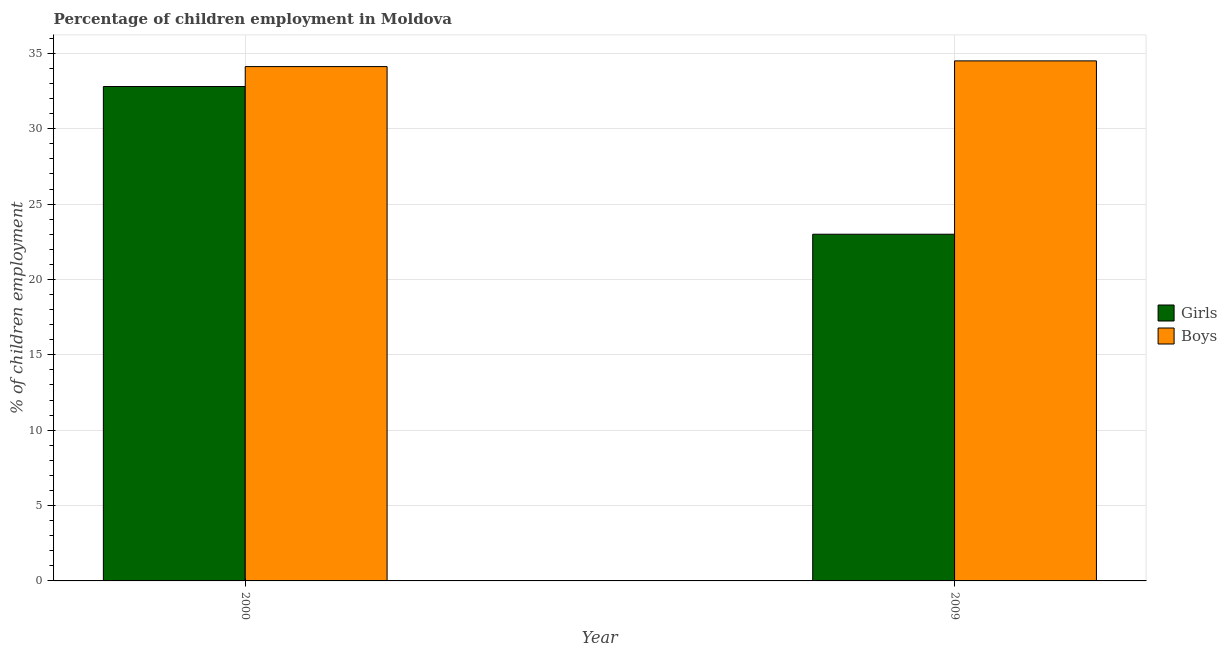How many bars are there on the 1st tick from the right?
Offer a terse response. 2. In how many cases, is the number of bars for a given year not equal to the number of legend labels?
Provide a short and direct response. 0. What is the percentage of employed boys in 2009?
Ensure brevity in your answer.  34.5. Across all years, what is the maximum percentage of employed boys?
Provide a succinct answer. 34.5. Across all years, what is the minimum percentage of employed boys?
Your answer should be very brief. 34.12. What is the total percentage of employed girls in the graph?
Provide a short and direct response. 55.8. What is the difference between the percentage of employed boys in 2000 and that in 2009?
Make the answer very short. -0.38. What is the difference between the percentage of employed girls in 2009 and the percentage of employed boys in 2000?
Ensure brevity in your answer.  -9.8. What is the average percentage of employed boys per year?
Keep it short and to the point. 34.31. In how many years, is the percentage of employed girls greater than 18 %?
Offer a very short reply. 2. What is the ratio of the percentage of employed boys in 2000 to that in 2009?
Offer a very short reply. 0.99. What does the 1st bar from the left in 2009 represents?
Keep it short and to the point. Girls. What does the 2nd bar from the right in 2009 represents?
Provide a succinct answer. Girls. How many years are there in the graph?
Your answer should be very brief. 2. What is the difference between two consecutive major ticks on the Y-axis?
Provide a short and direct response. 5. Are the values on the major ticks of Y-axis written in scientific E-notation?
Offer a terse response. No. How are the legend labels stacked?
Provide a succinct answer. Vertical. What is the title of the graph?
Your response must be concise. Percentage of children employment in Moldova. What is the label or title of the X-axis?
Your response must be concise. Year. What is the label or title of the Y-axis?
Your answer should be very brief. % of children employment. What is the % of children employment in Girls in 2000?
Your response must be concise. 32.8. What is the % of children employment of Boys in 2000?
Keep it short and to the point. 34.12. What is the % of children employment of Girls in 2009?
Offer a very short reply. 23. What is the % of children employment in Boys in 2009?
Give a very brief answer. 34.5. Across all years, what is the maximum % of children employment of Girls?
Offer a very short reply. 32.8. Across all years, what is the maximum % of children employment of Boys?
Keep it short and to the point. 34.5. Across all years, what is the minimum % of children employment in Girls?
Offer a terse response. 23. Across all years, what is the minimum % of children employment of Boys?
Make the answer very short. 34.12. What is the total % of children employment of Girls in the graph?
Offer a very short reply. 55.8. What is the total % of children employment in Boys in the graph?
Keep it short and to the point. 68.62. What is the difference between the % of children employment in Girls in 2000 and that in 2009?
Give a very brief answer. 9.8. What is the difference between the % of children employment of Boys in 2000 and that in 2009?
Make the answer very short. -0.38. What is the average % of children employment in Girls per year?
Offer a terse response. 27.9. What is the average % of children employment of Boys per year?
Offer a terse response. 34.31. In the year 2000, what is the difference between the % of children employment in Girls and % of children employment in Boys?
Offer a terse response. -1.32. What is the ratio of the % of children employment in Girls in 2000 to that in 2009?
Make the answer very short. 1.43. What is the difference between the highest and the second highest % of children employment in Girls?
Your response must be concise. 9.8. What is the difference between the highest and the second highest % of children employment of Boys?
Make the answer very short. 0.38. What is the difference between the highest and the lowest % of children employment of Boys?
Keep it short and to the point. 0.38. 